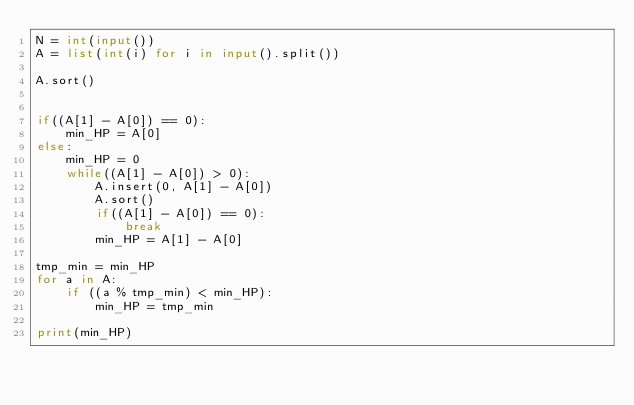Convert code to text. <code><loc_0><loc_0><loc_500><loc_500><_Python_>N = int(input())
A = list(int(i) for i in input().split())

A.sort()


if((A[1] - A[0]) == 0):
    min_HP = A[0]
else:
    min_HP = 0
    while((A[1] - A[0]) > 0):
        A.insert(0, A[1] - A[0])
        A.sort()
        if((A[1] - A[0]) == 0):
            break
        min_HP = A[1] - A[0]

tmp_min = min_HP
for a in A:
    if ((a % tmp_min) < min_HP):
        min_HP = tmp_min

print(min_HP)</code> 